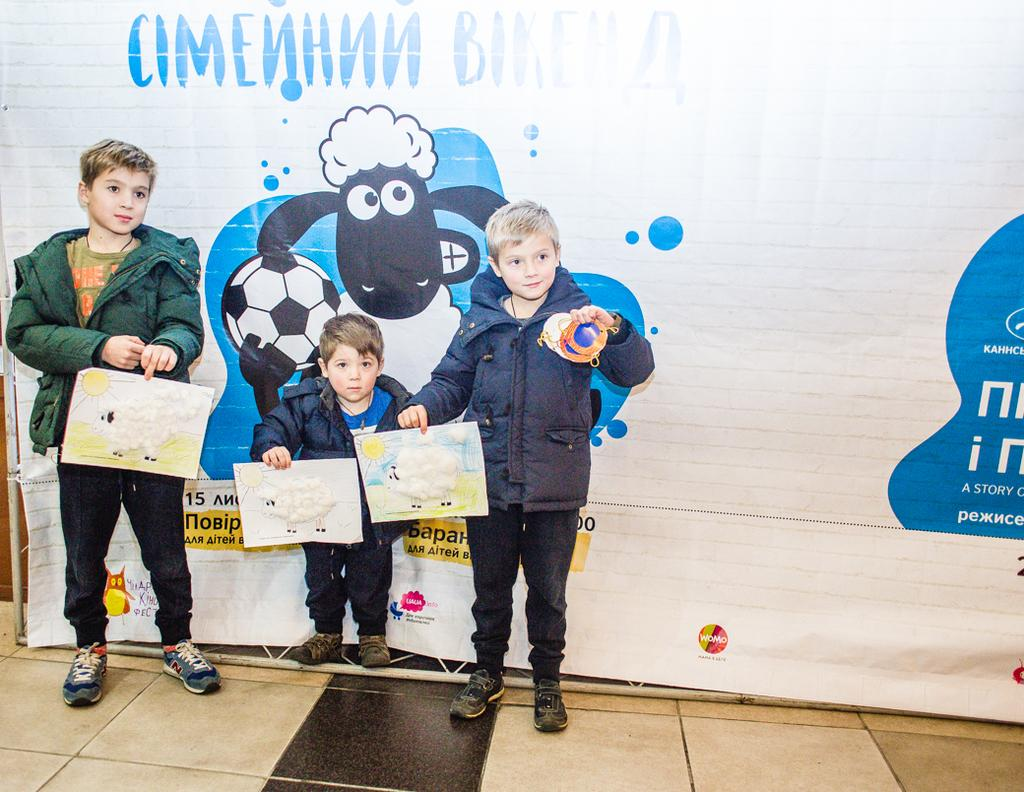How many children are in the image? There are three children in the image. What are the children doing in the image? The children are standing and holding papers. What else can be seen in the image besides the children? There is a banner visible in the image. What type of smoke can be seen coming from the banner in the image? There is no smoke present in the image; only the children and the banner are visible. 